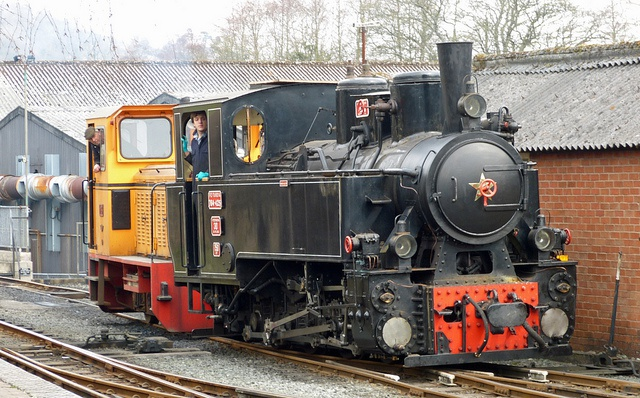Describe the objects in this image and their specific colors. I can see train in white, black, gray, darkgray, and lightgray tones, people in white, gray, black, and darkblue tones, and people in white, gray, and black tones in this image. 